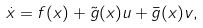<formula> <loc_0><loc_0><loc_500><loc_500>\dot { x } = f ( x ) + \tilde { g } ( x ) u + \bar { g } ( x ) v ,</formula> 